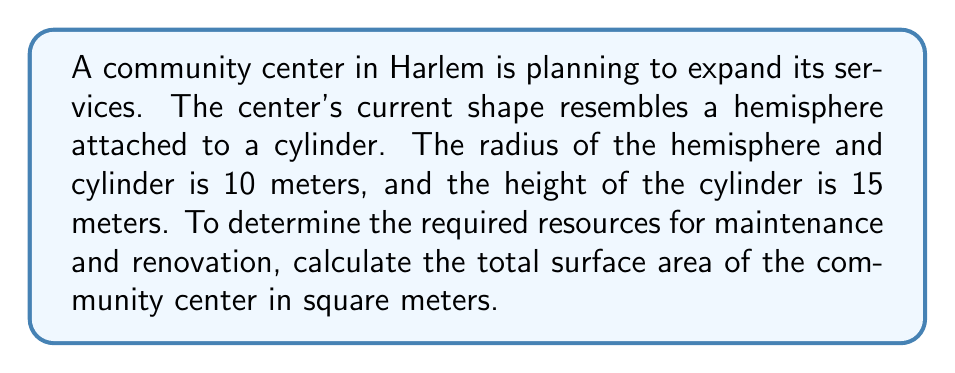What is the answer to this math problem? Let's break this problem down into steps:

1) The community center consists of two parts: a hemisphere and a cylinder.

2) For the hemisphere:
   - The surface area of a hemisphere is given by the formula: $A_h = 2\pi r^2$
   - Where $r$ is the radius, which is 10 meters
   - $A_h = 2\pi (10)^2 = 200\pi$ square meters

3) For the cylinder:
   - The surface area of a cylinder (excluding the bases) is given by: $A_c = 2\pi rh$
   - Where $r$ is the radius (10 meters) and $h$ is the height (15 meters)
   - $A_c = 2\pi (10)(15) = 300\pi$ square meters
   - We also need to include the bottom circular base: $A_b = \pi r^2 = \pi (10)^2 = 100\pi$ square meters

4) Total surface area:
   $$A_{total} = A_h + A_c + A_b$$
   $$A_{total} = 200\pi + 300\pi + 100\pi = 600\pi \text{ square meters}$$

5) To get the final answer in square meters:
   $$A_{total} = 600\pi \approx 1884.96 \text{ square meters}$$
Answer: The total surface area of the community center is approximately 1884.96 square meters. 